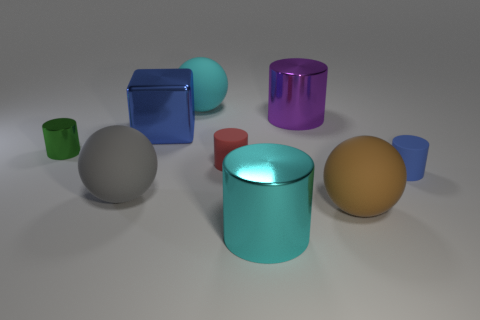How many yellow objects are tiny rubber cylinders or metal cylinders? In the image, there is one yellow object that appears to be a cylinder, although it's not possible to determine the material from the image alone. 